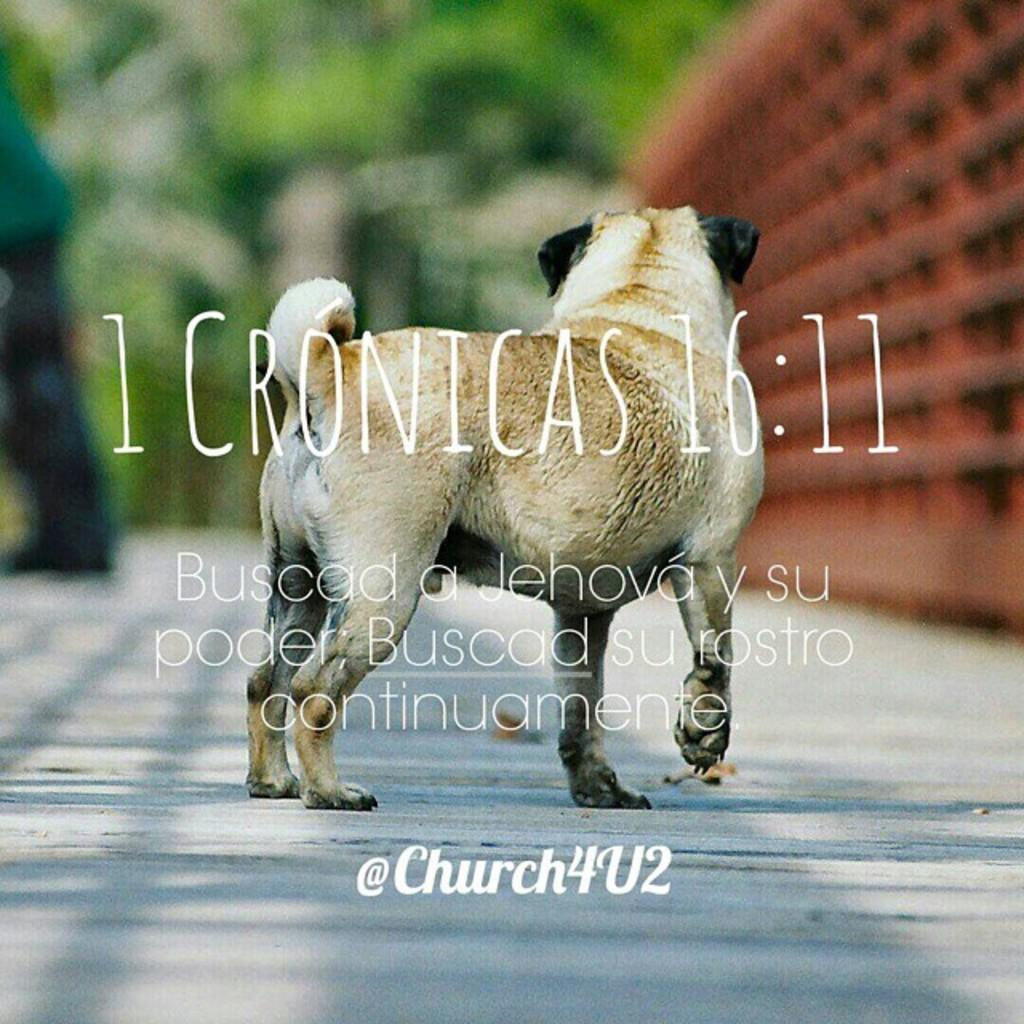What is present on the wall in the image? There is a poster in the image. What type of animal can be seen on the floor in the image? There is a dog standing on the floor in the image. What can be read or seen on the front side of the image? There is text visible on the front side of the image. How would you describe the background of the image? The background of the image is blurry. What type of voyage is the dog embarking on in the image? There is no indication of a voyage in the image; it simply shows a dog standing on the floor. How does the poster promote peace in the image? The poster does not specifically promote peace in the image; it is just a poster on the wall. 